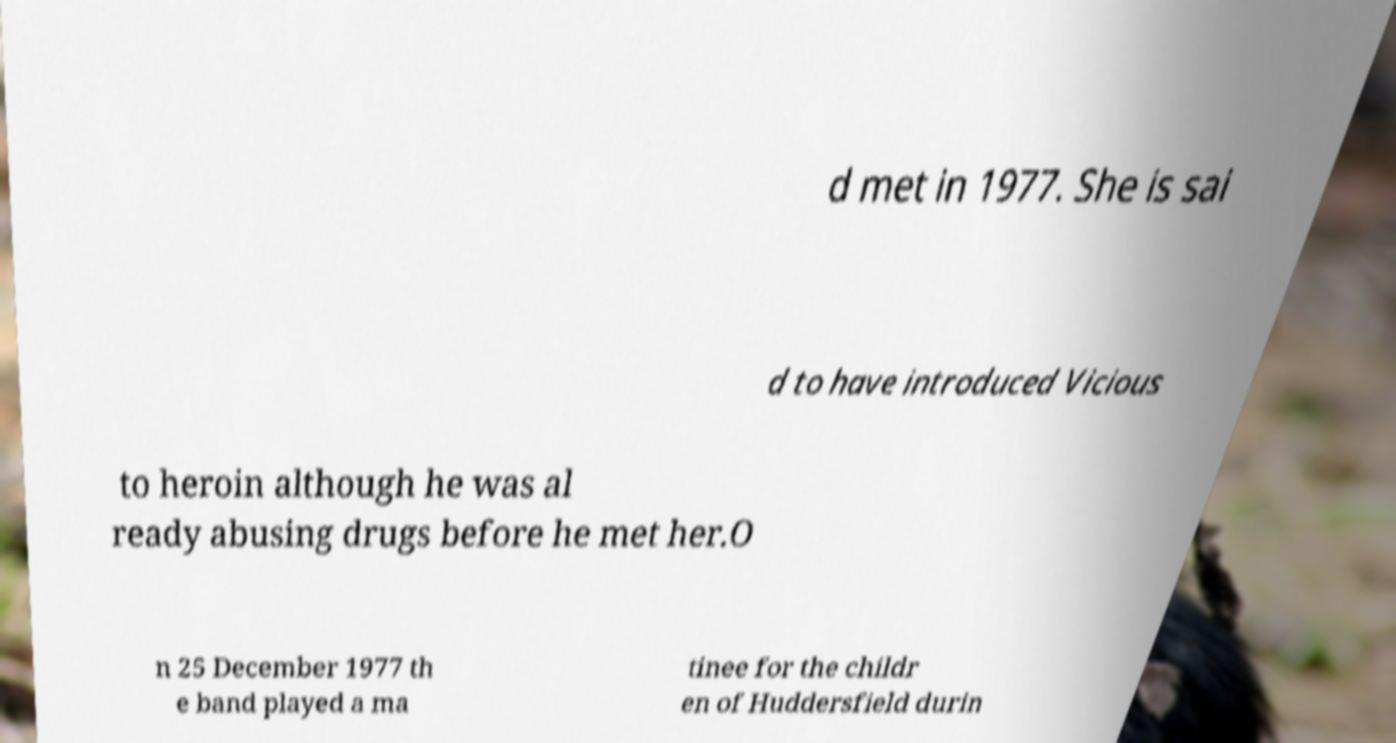I need the written content from this picture converted into text. Can you do that? d met in 1977. She is sai d to have introduced Vicious to heroin although he was al ready abusing drugs before he met her.O n 25 December 1977 th e band played a ma tinee for the childr en of Huddersfield durin 